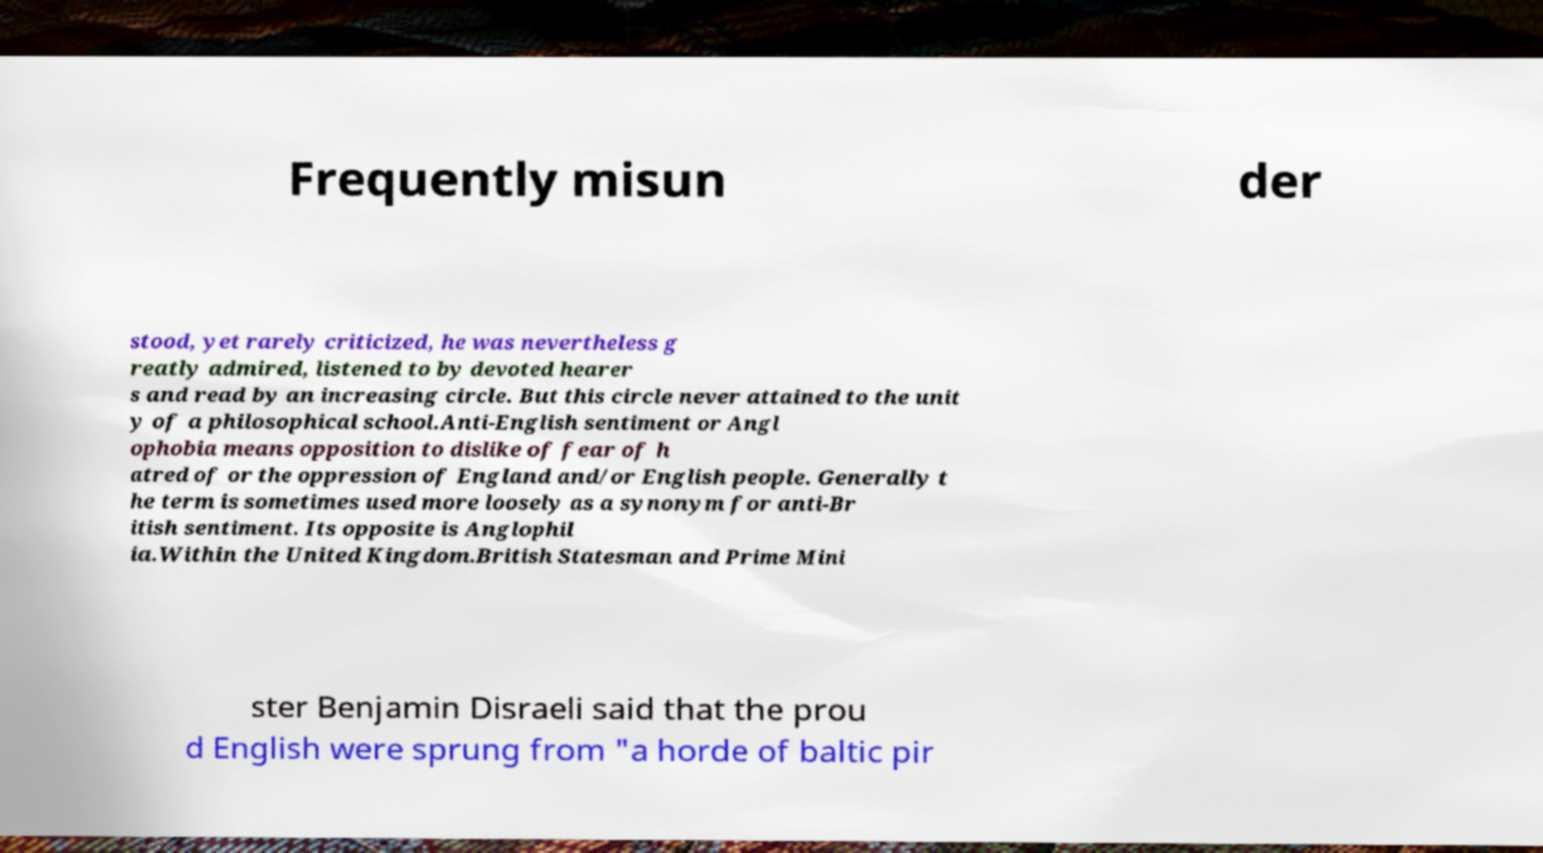What messages or text are displayed in this image? I need them in a readable, typed format. Frequently misun der stood, yet rarely criticized, he was nevertheless g reatly admired, listened to by devoted hearer s and read by an increasing circle. But this circle never attained to the unit y of a philosophical school.Anti-English sentiment or Angl ophobia means opposition to dislike of fear of h atred of or the oppression of England and/or English people. Generally t he term is sometimes used more loosely as a synonym for anti-Br itish sentiment. Its opposite is Anglophil ia.Within the United Kingdom.British Statesman and Prime Mini ster Benjamin Disraeli said that the prou d English were sprung from "a horde of baltic pir 